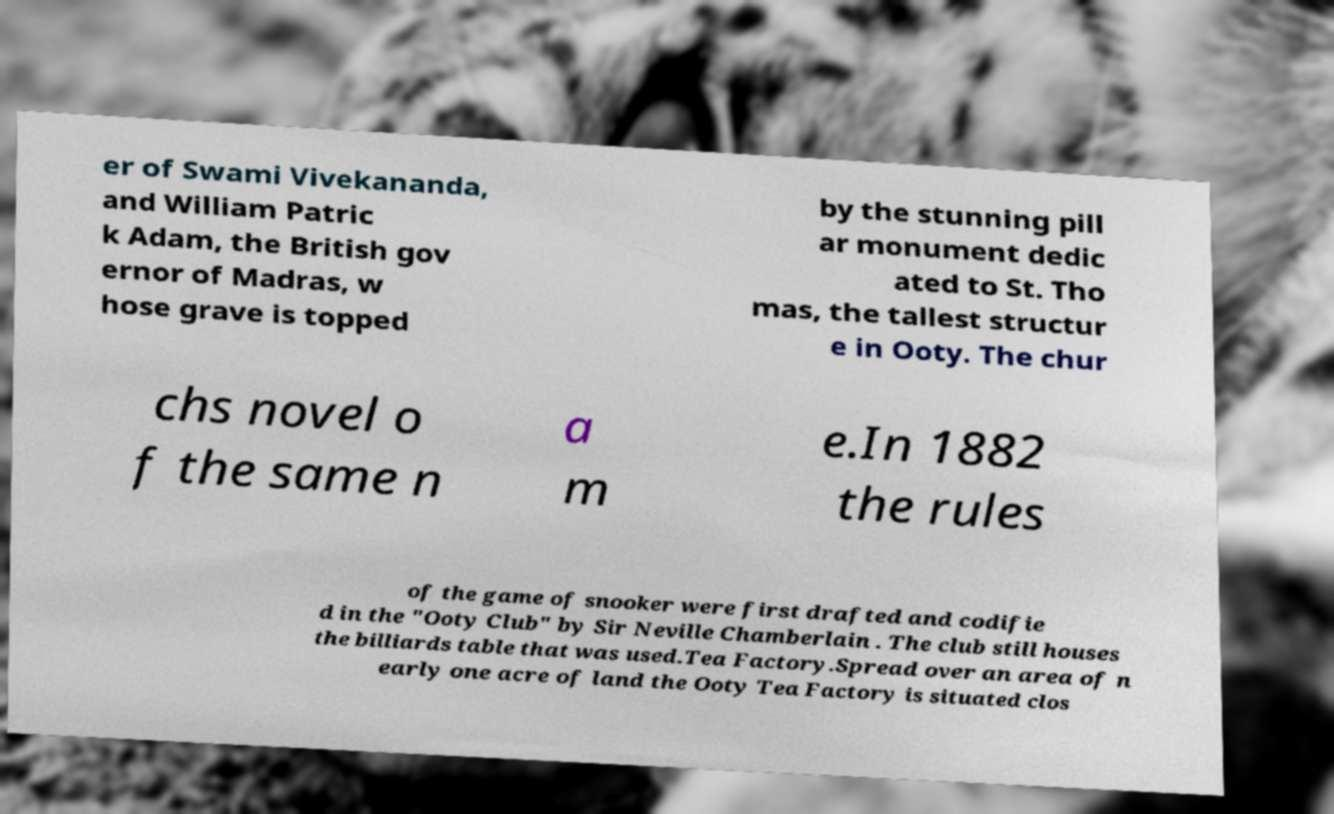For documentation purposes, I need the text within this image transcribed. Could you provide that? er of Swami Vivekananda, and William Patric k Adam, the British gov ernor of Madras, w hose grave is topped by the stunning pill ar monument dedic ated to St. Tho mas, the tallest structur e in Ooty. The chur chs novel o f the same n a m e.In 1882 the rules of the game of snooker were first drafted and codifie d in the "Ooty Club" by Sir Neville Chamberlain . The club still houses the billiards table that was used.Tea Factory.Spread over an area of n early one acre of land the Ooty Tea Factory is situated clos 